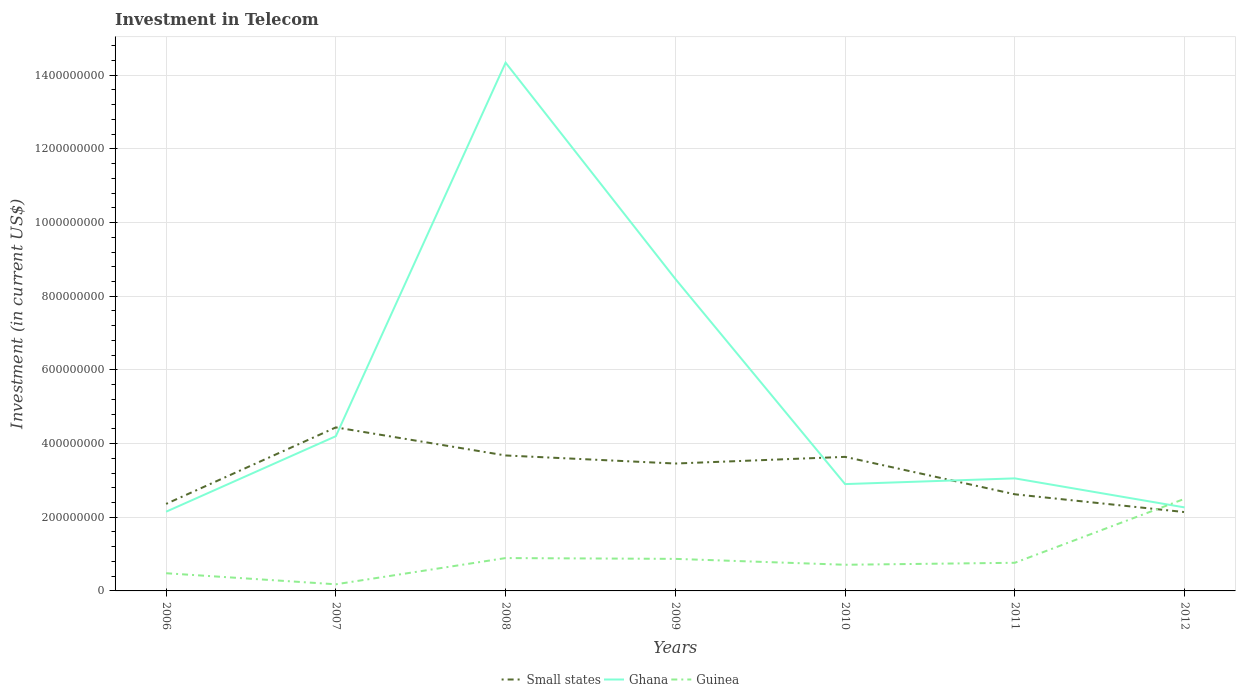Does the line corresponding to Ghana intersect with the line corresponding to Guinea?
Provide a short and direct response. Yes. Across all years, what is the maximum amount invested in telecom in Ghana?
Make the answer very short. 2.15e+08. In which year was the amount invested in telecom in Ghana maximum?
Provide a succinct answer. 2006. What is the total amount invested in telecom in Guinea in the graph?
Your answer should be very brief. -1.63e+08. What is the difference between the highest and the second highest amount invested in telecom in Ghana?
Provide a short and direct response. 1.22e+09. What is the difference between the highest and the lowest amount invested in telecom in Small states?
Make the answer very short. 4. Is the amount invested in telecom in Small states strictly greater than the amount invested in telecom in Guinea over the years?
Your answer should be very brief. No. Are the values on the major ticks of Y-axis written in scientific E-notation?
Ensure brevity in your answer.  No. Does the graph contain any zero values?
Give a very brief answer. No. Where does the legend appear in the graph?
Your answer should be compact. Bottom center. What is the title of the graph?
Give a very brief answer. Investment in Telecom. Does "Malta" appear as one of the legend labels in the graph?
Your response must be concise. No. What is the label or title of the X-axis?
Offer a terse response. Years. What is the label or title of the Y-axis?
Ensure brevity in your answer.  Investment (in current US$). What is the Investment (in current US$) in Small states in 2006?
Ensure brevity in your answer.  2.36e+08. What is the Investment (in current US$) in Ghana in 2006?
Offer a terse response. 2.15e+08. What is the Investment (in current US$) of Guinea in 2006?
Your response must be concise. 4.80e+07. What is the Investment (in current US$) of Small states in 2007?
Provide a short and direct response. 4.44e+08. What is the Investment (in current US$) of Ghana in 2007?
Keep it short and to the point. 4.20e+08. What is the Investment (in current US$) of Guinea in 2007?
Keep it short and to the point. 1.80e+07. What is the Investment (in current US$) of Small states in 2008?
Offer a very short reply. 3.68e+08. What is the Investment (in current US$) in Ghana in 2008?
Give a very brief answer. 1.43e+09. What is the Investment (in current US$) of Guinea in 2008?
Offer a terse response. 8.92e+07. What is the Investment (in current US$) in Small states in 2009?
Give a very brief answer. 3.46e+08. What is the Investment (in current US$) in Ghana in 2009?
Your answer should be compact. 8.47e+08. What is the Investment (in current US$) in Guinea in 2009?
Make the answer very short. 8.70e+07. What is the Investment (in current US$) of Small states in 2010?
Your answer should be compact. 3.64e+08. What is the Investment (in current US$) in Ghana in 2010?
Your response must be concise. 2.90e+08. What is the Investment (in current US$) in Guinea in 2010?
Offer a terse response. 7.10e+07. What is the Investment (in current US$) of Small states in 2011?
Your response must be concise. 2.62e+08. What is the Investment (in current US$) in Ghana in 2011?
Ensure brevity in your answer.  3.06e+08. What is the Investment (in current US$) in Guinea in 2011?
Provide a succinct answer. 7.64e+07. What is the Investment (in current US$) in Small states in 2012?
Make the answer very short. 2.14e+08. What is the Investment (in current US$) in Ghana in 2012?
Give a very brief answer. 2.27e+08. What is the Investment (in current US$) of Guinea in 2012?
Offer a terse response. 2.50e+08. Across all years, what is the maximum Investment (in current US$) in Small states?
Ensure brevity in your answer.  4.44e+08. Across all years, what is the maximum Investment (in current US$) in Ghana?
Ensure brevity in your answer.  1.43e+09. Across all years, what is the maximum Investment (in current US$) of Guinea?
Offer a very short reply. 2.50e+08. Across all years, what is the minimum Investment (in current US$) of Small states?
Offer a terse response. 2.14e+08. Across all years, what is the minimum Investment (in current US$) in Ghana?
Offer a terse response. 2.15e+08. Across all years, what is the minimum Investment (in current US$) in Guinea?
Give a very brief answer. 1.80e+07. What is the total Investment (in current US$) of Small states in the graph?
Offer a very short reply. 2.23e+09. What is the total Investment (in current US$) of Ghana in the graph?
Offer a very short reply. 3.74e+09. What is the total Investment (in current US$) of Guinea in the graph?
Your answer should be compact. 6.40e+08. What is the difference between the Investment (in current US$) in Small states in 2006 and that in 2007?
Offer a very short reply. -2.08e+08. What is the difference between the Investment (in current US$) in Ghana in 2006 and that in 2007?
Provide a short and direct response. -2.05e+08. What is the difference between the Investment (in current US$) in Guinea in 2006 and that in 2007?
Give a very brief answer. 3.00e+07. What is the difference between the Investment (in current US$) of Small states in 2006 and that in 2008?
Give a very brief answer. -1.31e+08. What is the difference between the Investment (in current US$) in Ghana in 2006 and that in 2008?
Keep it short and to the point. -1.22e+09. What is the difference between the Investment (in current US$) of Guinea in 2006 and that in 2008?
Provide a short and direct response. -4.12e+07. What is the difference between the Investment (in current US$) of Small states in 2006 and that in 2009?
Provide a succinct answer. -1.10e+08. What is the difference between the Investment (in current US$) in Ghana in 2006 and that in 2009?
Offer a terse response. -6.32e+08. What is the difference between the Investment (in current US$) of Guinea in 2006 and that in 2009?
Your answer should be compact. -3.90e+07. What is the difference between the Investment (in current US$) in Small states in 2006 and that in 2010?
Keep it short and to the point. -1.28e+08. What is the difference between the Investment (in current US$) of Ghana in 2006 and that in 2010?
Your response must be concise. -7.50e+07. What is the difference between the Investment (in current US$) of Guinea in 2006 and that in 2010?
Your answer should be compact. -2.30e+07. What is the difference between the Investment (in current US$) in Small states in 2006 and that in 2011?
Give a very brief answer. -2.61e+07. What is the difference between the Investment (in current US$) of Ghana in 2006 and that in 2011?
Offer a very short reply. -9.05e+07. What is the difference between the Investment (in current US$) of Guinea in 2006 and that in 2011?
Keep it short and to the point. -2.84e+07. What is the difference between the Investment (in current US$) in Small states in 2006 and that in 2012?
Provide a short and direct response. 2.22e+07. What is the difference between the Investment (in current US$) of Ghana in 2006 and that in 2012?
Ensure brevity in your answer.  -1.17e+07. What is the difference between the Investment (in current US$) of Guinea in 2006 and that in 2012?
Ensure brevity in your answer.  -2.02e+08. What is the difference between the Investment (in current US$) in Small states in 2007 and that in 2008?
Offer a terse response. 7.62e+07. What is the difference between the Investment (in current US$) in Ghana in 2007 and that in 2008?
Offer a very short reply. -1.01e+09. What is the difference between the Investment (in current US$) of Guinea in 2007 and that in 2008?
Offer a very short reply. -7.12e+07. What is the difference between the Investment (in current US$) of Small states in 2007 and that in 2009?
Ensure brevity in your answer.  9.81e+07. What is the difference between the Investment (in current US$) of Ghana in 2007 and that in 2009?
Your answer should be very brief. -4.27e+08. What is the difference between the Investment (in current US$) of Guinea in 2007 and that in 2009?
Provide a short and direct response. -6.90e+07. What is the difference between the Investment (in current US$) of Small states in 2007 and that in 2010?
Your answer should be very brief. 8.00e+07. What is the difference between the Investment (in current US$) of Ghana in 2007 and that in 2010?
Offer a very short reply. 1.30e+08. What is the difference between the Investment (in current US$) in Guinea in 2007 and that in 2010?
Make the answer very short. -5.30e+07. What is the difference between the Investment (in current US$) in Small states in 2007 and that in 2011?
Offer a terse response. 1.82e+08. What is the difference between the Investment (in current US$) of Ghana in 2007 and that in 2011?
Offer a terse response. 1.14e+08. What is the difference between the Investment (in current US$) of Guinea in 2007 and that in 2011?
Keep it short and to the point. -5.84e+07. What is the difference between the Investment (in current US$) in Small states in 2007 and that in 2012?
Your answer should be compact. 2.30e+08. What is the difference between the Investment (in current US$) of Ghana in 2007 and that in 2012?
Provide a succinct answer. 1.93e+08. What is the difference between the Investment (in current US$) in Guinea in 2007 and that in 2012?
Your answer should be compact. -2.32e+08. What is the difference between the Investment (in current US$) of Small states in 2008 and that in 2009?
Keep it short and to the point. 2.19e+07. What is the difference between the Investment (in current US$) in Ghana in 2008 and that in 2009?
Keep it short and to the point. 5.87e+08. What is the difference between the Investment (in current US$) in Guinea in 2008 and that in 2009?
Offer a very short reply. 2.20e+06. What is the difference between the Investment (in current US$) of Small states in 2008 and that in 2010?
Offer a terse response. 3.81e+06. What is the difference between the Investment (in current US$) of Ghana in 2008 and that in 2010?
Make the answer very short. 1.14e+09. What is the difference between the Investment (in current US$) in Guinea in 2008 and that in 2010?
Give a very brief answer. 1.82e+07. What is the difference between the Investment (in current US$) in Small states in 2008 and that in 2011?
Provide a succinct answer. 1.05e+08. What is the difference between the Investment (in current US$) in Ghana in 2008 and that in 2011?
Offer a very short reply. 1.13e+09. What is the difference between the Investment (in current US$) of Guinea in 2008 and that in 2011?
Provide a succinct answer. 1.28e+07. What is the difference between the Investment (in current US$) of Small states in 2008 and that in 2012?
Provide a succinct answer. 1.54e+08. What is the difference between the Investment (in current US$) of Ghana in 2008 and that in 2012?
Your answer should be very brief. 1.21e+09. What is the difference between the Investment (in current US$) in Guinea in 2008 and that in 2012?
Your answer should be very brief. -1.61e+08. What is the difference between the Investment (in current US$) of Small states in 2009 and that in 2010?
Offer a terse response. -1.81e+07. What is the difference between the Investment (in current US$) of Ghana in 2009 and that in 2010?
Your answer should be very brief. 5.57e+08. What is the difference between the Investment (in current US$) in Guinea in 2009 and that in 2010?
Ensure brevity in your answer.  1.60e+07. What is the difference between the Investment (in current US$) in Small states in 2009 and that in 2011?
Your response must be concise. 8.35e+07. What is the difference between the Investment (in current US$) in Ghana in 2009 and that in 2011?
Your answer should be very brief. 5.42e+08. What is the difference between the Investment (in current US$) of Guinea in 2009 and that in 2011?
Make the answer very short. 1.06e+07. What is the difference between the Investment (in current US$) of Small states in 2009 and that in 2012?
Keep it short and to the point. 1.32e+08. What is the difference between the Investment (in current US$) of Ghana in 2009 and that in 2012?
Offer a terse response. 6.20e+08. What is the difference between the Investment (in current US$) in Guinea in 2009 and that in 2012?
Ensure brevity in your answer.  -1.63e+08. What is the difference between the Investment (in current US$) in Small states in 2010 and that in 2011?
Your answer should be compact. 1.02e+08. What is the difference between the Investment (in current US$) of Ghana in 2010 and that in 2011?
Your response must be concise. -1.55e+07. What is the difference between the Investment (in current US$) in Guinea in 2010 and that in 2011?
Your answer should be very brief. -5.40e+06. What is the difference between the Investment (in current US$) in Small states in 2010 and that in 2012?
Provide a short and direct response. 1.50e+08. What is the difference between the Investment (in current US$) of Ghana in 2010 and that in 2012?
Make the answer very short. 6.33e+07. What is the difference between the Investment (in current US$) in Guinea in 2010 and that in 2012?
Provide a succinct answer. -1.79e+08. What is the difference between the Investment (in current US$) in Small states in 2011 and that in 2012?
Offer a very short reply. 4.83e+07. What is the difference between the Investment (in current US$) in Ghana in 2011 and that in 2012?
Ensure brevity in your answer.  7.88e+07. What is the difference between the Investment (in current US$) in Guinea in 2011 and that in 2012?
Give a very brief answer. -1.74e+08. What is the difference between the Investment (in current US$) of Small states in 2006 and the Investment (in current US$) of Ghana in 2007?
Ensure brevity in your answer.  -1.84e+08. What is the difference between the Investment (in current US$) of Small states in 2006 and the Investment (in current US$) of Guinea in 2007?
Offer a very short reply. 2.18e+08. What is the difference between the Investment (in current US$) in Ghana in 2006 and the Investment (in current US$) in Guinea in 2007?
Your answer should be very brief. 1.97e+08. What is the difference between the Investment (in current US$) in Small states in 2006 and the Investment (in current US$) in Ghana in 2008?
Your response must be concise. -1.20e+09. What is the difference between the Investment (in current US$) in Small states in 2006 and the Investment (in current US$) in Guinea in 2008?
Your answer should be compact. 1.47e+08. What is the difference between the Investment (in current US$) of Ghana in 2006 and the Investment (in current US$) of Guinea in 2008?
Provide a short and direct response. 1.26e+08. What is the difference between the Investment (in current US$) of Small states in 2006 and the Investment (in current US$) of Ghana in 2009?
Offer a very short reply. -6.11e+08. What is the difference between the Investment (in current US$) of Small states in 2006 and the Investment (in current US$) of Guinea in 2009?
Your answer should be very brief. 1.49e+08. What is the difference between the Investment (in current US$) in Ghana in 2006 and the Investment (in current US$) in Guinea in 2009?
Your answer should be very brief. 1.28e+08. What is the difference between the Investment (in current US$) of Small states in 2006 and the Investment (in current US$) of Ghana in 2010?
Offer a very short reply. -5.38e+07. What is the difference between the Investment (in current US$) of Small states in 2006 and the Investment (in current US$) of Guinea in 2010?
Offer a very short reply. 1.65e+08. What is the difference between the Investment (in current US$) of Ghana in 2006 and the Investment (in current US$) of Guinea in 2010?
Your answer should be very brief. 1.44e+08. What is the difference between the Investment (in current US$) in Small states in 2006 and the Investment (in current US$) in Ghana in 2011?
Offer a terse response. -6.93e+07. What is the difference between the Investment (in current US$) in Small states in 2006 and the Investment (in current US$) in Guinea in 2011?
Provide a succinct answer. 1.60e+08. What is the difference between the Investment (in current US$) of Ghana in 2006 and the Investment (in current US$) of Guinea in 2011?
Keep it short and to the point. 1.39e+08. What is the difference between the Investment (in current US$) in Small states in 2006 and the Investment (in current US$) in Ghana in 2012?
Make the answer very short. 9.53e+06. What is the difference between the Investment (in current US$) of Small states in 2006 and the Investment (in current US$) of Guinea in 2012?
Offer a terse response. -1.38e+07. What is the difference between the Investment (in current US$) in Ghana in 2006 and the Investment (in current US$) in Guinea in 2012?
Offer a terse response. -3.50e+07. What is the difference between the Investment (in current US$) in Small states in 2007 and the Investment (in current US$) in Ghana in 2008?
Your answer should be very brief. -9.90e+08. What is the difference between the Investment (in current US$) of Small states in 2007 and the Investment (in current US$) of Guinea in 2008?
Your response must be concise. 3.55e+08. What is the difference between the Investment (in current US$) of Ghana in 2007 and the Investment (in current US$) of Guinea in 2008?
Your answer should be very brief. 3.31e+08. What is the difference between the Investment (in current US$) in Small states in 2007 and the Investment (in current US$) in Ghana in 2009?
Your answer should be compact. -4.03e+08. What is the difference between the Investment (in current US$) in Small states in 2007 and the Investment (in current US$) in Guinea in 2009?
Keep it short and to the point. 3.57e+08. What is the difference between the Investment (in current US$) in Ghana in 2007 and the Investment (in current US$) in Guinea in 2009?
Offer a very short reply. 3.33e+08. What is the difference between the Investment (in current US$) in Small states in 2007 and the Investment (in current US$) in Ghana in 2010?
Provide a short and direct response. 1.54e+08. What is the difference between the Investment (in current US$) of Small states in 2007 and the Investment (in current US$) of Guinea in 2010?
Offer a very short reply. 3.73e+08. What is the difference between the Investment (in current US$) of Ghana in 2007 and the Investment (in current US$) of Guinea in 2010?
Make the answer very short. 3.49e+08. What is the difference between the Investment (in current US$) of Small states in 2007 and the Investment (in current US$) of Ghana in 2011?
Keep it short and to the point. 1.38e+08. What is the difference between the Investment (in current US$) of Small states in 2007 and the Investment (in current US$) of Guinea in 2011?
Provide a short and direct response. 3.68e+08. What is the difference between the Investment (in current US$) in Ghana in 2007 and the Investment (in current US$) in Guinea in 2011?
Give a very brief answer. 3.44e+08. What is the difference between the Investment (in current US$) in Small states in 2007 and the Investment (in current US$) in Ghana in 2012?
Offer a terse response. 2.17e+08. What is the difference between the Investment (in current US$) in Small states in 2007 and the Investment (in current US$) in Guinea in 2012?
Offer a terse response. 1.94e+08. What is the difference between the Investment (in current US$) of Ghana in 2007 and the Investment (in current US$) of Guinea in 2012?
Offer a terse response. 1.70e+08. What is the difference between the Investment (in current US$) in Small states in 2008 and the Investment (in current US$) in Ghana in 2009?
Provide a short and direct response. -4.79e+08. What is the difference between the Investment (in current US$) in Small states in 2008 and the Investment (in current US$) in Guinea in 2009?
Give a very brief answer. 2.81e+08. What is the difference between the Investment (in current US$) of Ghana in 2008 and the Investment (in current US$) of Guinea in 2009?
Give a very brief answer. 1.35e+09. What is the difference between the Investment (in current US$) of Small states in 2008 and the Investment (in current US$) of Ghana in 2010?
Your answer should be compact. 7.77e+07. What is the difference between the Investment (in current US$) of Small states in 2008 and the Investment (in current US$) of Guinea in 2010?
Ensure brevity in your answer.  2.97e+08. What is the difference between the Investment (in current US$) of Ghana in 2008 and the Investment (in current US$) of Guinea in 2010?
Offer a very short reply. 1.36e+09. What is the difference between the Investment (in current US$) in Small states in 2008 and the Investment (in current US$) in Ghana in 2011?
Your answer should be compact. 6.22e+07. What is the difference between the Investment (in current US$) of Small states in 2008 and the Investment (in current US$) of Guinea in 2011?
Provide a short and direct response. 2.91e+08. What is the difference between the Investment (in current US$) in Ghana in 2008 and the Investment (in current US$) in Guinea in 2011?
Make the answer very short. 1.36e+09. What is the difference between the Investment (in current US$) of Small states in 2008 and the Investment (in current US$) of Ghana in 2012?
Your response must be concise. 1.41e+08. What is the difference between the Investment (in current US$) of Small states in 2008 and the Investment (in current US$) of Guinea in 2012?
Your answer should be compact. 1.18e+08. What is the difference between the Investment (in current US$) in Ghana in 2008 and the Investment (in current US$) in Guinea in 2012?
Your answer should be very brief. 1.18e+09. What is the difference between the Investment (in current US$) of Small states in 2009 and the Investment (in current US$) of Ghana in 2010?
Offer a very short reply. 5.58e+07. What is the difference between the Investment (in current US$) in Small states in 2009 and the Investment (in current US$) in Guinea in 2010?
Ensure brevity in your answer.  2.75e+08. What is the difference between the Investment (in current US$) of Ghana in 2009 and the Investment (in current US$) of Guinea in 2010?
Offer a very short reply. 7.76e+08. What is the difference between the Investment (in current US$) of Small states in 2009 and the Investment (in current US$) of Ghana in 2011?
Provide a succinct answer. 4.03e+07. What is the difference between the Investment (in current US$) in Small states in 2009 and the Investment (in current US$) in Guinea in 2011?
Your answer should be very brief. 2.69e+08. What is the difference between the Investment (in current US$) of Ghana in 2009 and the Investment (in current US$) of Guinea in 2011?
Your response must be concise. 7.71e+08. What is the difference between the Investment (in current US$) of Small states in 2009 and the Investment (in current US$) of Ghana in 2012?
Make the answer very short. 1.19e+08. What is the difference between the Investment (in current US$) of Small states in 2009 and the Investment (in current US$) of Guinea in 2012?
Offer a very short reply. 9.58e+07. What is the difference between the Investment (in current US$) of Ghana in 2009 and the Investment (in current US$) of Guinea in 2012?
Provide a succinct answer. 5.97e+08. What is the difference between the Investment (in current US$) of Small states in 2010 and the Investment (in current US$) of Ghana in 2011?
Keep it short and to the point. 5.84e+07. What is the difference between the Investment (in current US$) of Small states in 2010 and the Investment (in current US$) of Guinea in 2011?
Offer a terse response. 2.88e+08. What is the difference between the Investment (in current US$) in Ghana in 2010 and the Investment (in current US$) in Guinea in 2011?
Offer a terse response. 2.14e+08. What is the difference between the Investment (in current US$) of Small states in 2010 and the Investment (in current US$) of Ghana in 2012?
Give a very brief answer. 1.37e+08. What is the difference between the Investment (in current US$) in Small states in 2010 and the Investment (in current US$) in Guinea in 2012?
Your answer should be very brief. 1.14e+08. What is the difference between the Investment (in current US$) of Ghana in 2010 and the Investment (in current US$) of Guinea in 2012?
Give a very brief answer. 4.00e+07. What is the difference between the Investment (in current US$) in Small states in 2011 and the Investment (in current US$) in Ghana in 2012?
Your answer should be compact. 3.56e+07. What is the difference between the Investment (in current US$) in Small states in 2011 and the Investment (in current US$) in Guinea in 2012?
Your answer should be very brief. 1.23e+07. What is the difference between the Investment (in current US$) in Ghana in 2011 and the Investment (in current US$) in Guinea in 2012?
Give a very brief answer. 5.55e+07. What is the average Investment (in current US$) in Small states per year?
Your response must be concise. 3.19e+08. What is the average Investment (in current US$) of Ghana per year?
Keep it short and to the point. 5.34e+08. What is the average Investment (in current US$) of Guinea per year?
Offer a terse response. 9.14e+07. In the year 2006, what is the difference between the Investment (in current US$) in Small states and Investment (in current US$) in Ghana?
Offer a terse response. 2.12e+07. In the year 2006, what is the difference between the Investment (in current US$) of Small states and Investment (in current US$) of Guinea?
Keep it short and to the point. 1.88e+08. In the year 2006, what is the difference between the Investment (in current US$) of Ghana and Investment (in current US$) of Guinea?
Offer a very short reply. 1.67e+08. In the year 2007, what is the difference between the Investment (in current US$) of Small states and Investment (in current US$) of Ghana?
Offer a terse response. 2.39e+07. In the year 2007, what is the difference between the Investment (in current US$) in Small states and Investment (in current US$) in Guinea?
Your answer should be very brief. 4.26e+08. In the year 2007, what is the difference between the Investment (in current US$) of Ghana and Investment (in current US$) of Guinea?
Make the answer very short. 4.02e+08. In the year 2008, what is the difference between the Investment (in current US$) in Small states and Investment (in current US$) in Ghana?
Your answer should be compact. -1.07e+09. In the year 2008, what is the difference between the Investment (in current US$) of Small states and Investment (in current US$) of Guinea?
Offer a terse response. 2.79e+08. In the year 2008, what is the difference between the Investment (in current US$) in Ghana and Investment (in current US$) in Guinea?
Keep it short and to the point. 1.34e+09. In the year 2009, what is the difference between the Investment (in current US$) of Small states and Investment (in current US$) of Ghana?
Your answer should be compact. -5.01e+08. In the year 2009, what is the difference between the Investment (in current US$) in Small states and Investment (in current US$) in Guinea?
Your response must be concise. 2.59e+08. In the year 2009, what is the difference between the Investment (in current US$) in Ghana and Investment (in current US$) in Guinea?
Make the answer very short. 7.60e+08. In the year 2010, what is the difference between the Investment (in current US$) of Small states and Investment (in current US$) of Ghana?
Keep it short and to the point. 7.39e+07. In the year 2010, what is the difference between the Investment (in current US$) of Small states and Investment (in current US$) of Guinea?
Your response must be concise. 2.93e+08. In the year 2010, what is the difference between the Investment (in current US$) of Ghana and Investment (in current US$) of Guinea?
Provide a short and direct response. 2.19e+08. In the year 2011, what is the difference between the Investment (in current US$) of Small states and Investment (in current US$) of Ghana?
Offer a very short reply. -4.32e+07. In the year 2011, what is the difference between the Investment (in current US$) of Small states and Investment (in current US$) of Guinea?
Offer a very short reply. 1.86e+08. In the year 2011, what is the difference between the Investment (in current US$) in Ghana and Investment (in current US$) in Guinea?
Ensure brevity in your answer.  2.29e+08. In the year 2012, what is the difference between the Investment (in current US$) in Small states and Investment (in current US$) in Ghana?
Your answer should be compact. -1.27e+07. In the year 2012, what is the difference between the Investment (in current US$) in Small states and Investment (in current US$) in Guinea?
Your answer should be very brief. -3.60e+07. In the year 2012, what is the difference between the Investment (in current US$) of Ghana and Investment (in current US$) of Guinea?
Offer a terse response. -2.33e+07. What is the ratio of the Investment (in current US$) of Small states in 2006 to that in 2007?
Your answer should be very brief. 0.53. What is the ratio of the Investment (in current US$) in Ghana in 2006 to that in 2007?
Provide a short and direct response. 0.51. What is the ratio of the Investment (in current US$) of Guinea in 2006 to that in 2007?
Provide a succinct answer. 2.67. What is the ratio of the Investment (in current US$) of Small states in 2006 to that in 2008?
Your answer should be compact. 0.64. What is the ratio of the Investment (in current US$) of Ghana in 2006 to that in 2008?
Your response must be concise. 0.15. What is the ratio of the Investment (in current US$) of Guinea in 2006 to that in 2008?
Keep it short and to the point. 0.54. What is the ratio of the Investment (in current US$) in Small states in 2006 to that in 2009?
Your answer should be compact. 0.68. What is the ratio of the Investment (in current US$) in Ghana in 2006 to that in 2009?
Your answer should be very brief. 0.25. What is the ratio of the Investment (in current US$) in Guinea in 2006 to that in 2009?
Your response must be concise. 0.55. What is the ratio of the Investment (in current US$) in Small states in 2006 to that in 2010?
Provide a succinct answer. 0.65. What is the ratio of the Investment (in current US$) of Ghana in 2006 to that in 2010?
Make the answer very short. 0.74. What is the ratio of the Investment (in current US$) in Guinea in 2006 to that in 2010?
Your response must be concise. 0.68. What is the ratio of the Investment (in current US$) in Small states in 2006 to that in 2011?
Provide a short and direct response. 0.9. What is the ratio of the Investment (in current US$) of Ghana in 2006 to that in 2011?
Keep it short and to the point. 0.7. What is the ratio of the Investment (in current US$) in Guinea in 2006 to that in 2011?
Your answer should be compact. 0.63. What is the ratio of the Investment (in current US$) in Small states in 2006 to that in 2012?
Give a very brief answer. 1.1. What is the ratio of the Investment (in current US$) of Ghana in 2006 to that in 2012?
Offer a terse response. 0.95. What is the ratio of the Investment (in current US$) in Guinea in 2006 to that in 2012?
Your response must be concise. 0.19. What is the ratio of the Investment (in current US$) in Small states in 2007 to that in 2008?
Make the answer very short. 1.21. What is the ratio of the Investment (in current US$) in Ghana in 2007 to that in 2008?
Make the answer very short. 0.29. What is the ratio of the Investment (in current US$) in Guinea in 2007 to that in 2008?
Your answer should be compact. 0.2. What is the ratio of the Investment (in current US$) of Small states in 2007 to that in 2009?
Give a very brief answer. 1.28. What is the ratio of the Investment (in current US$) of Ghana in 2007 to that in 2009?
Provide a short and direct response. 0.5. What is the ratio of the Investment (in current US$) in Guinea in 2007 to that in 2009?
Provide a succinct answer. 0.21. What is the ratio of the Investment (in current US$) of Small states in 2007 to that in 2010?
Provide a short and direct response. 1.22. What is the ratio of the Investment (in current US$) in Ghana in 2007 to that in 2010?
Your answer should be compact. 1.45. What is the ratio of the Investment (in current US$) in Guinea in 2007 to that in 2010?
Your response must be concise. 0.25. What is the ratio of the Investment (in current US$) of Small states in 2007 to that in 2011?
Give a very brief answer. 1.69. What is the ratio of the Investment (in current US$) in Ghana in 2007 to that in 2011?
Provide a short and direct response. 1.37. What is the ratio of the Investment (in current US$) in Guinea in 2007 to that in 2011?
Give a very brief answer. 0.24. What is the ratio of the Investment (in current US$) in Small states in 2007 to that in 2012?
Provide a short and direct response. 2.07. What is the ratio of the Investment (in current US$) in Ghana in 2007 to that in 2012?
Offer a terse response. 1.85. What is the ratio of the Investment (in current US$) in Guinea in 2007 to that in 2012?
Ensure brevity in your answer.  0.07. What is the ratio of the Investment (in current US$) of Small states in 2008 to that in 2009?
Your answer should be compact. 1.06. What is the ratio of the Investment (in current US$) of Ghana in 2008 to that in 2009?
Offer a terse response. 1.69. What is the ratio of the Investment (in current US$) of Guinea in 2008 to that in 2009?
Keep it short and to the point. 1.03. What is the ratio of the Investment (in current US$) in Small states in 2008 to that in 2010?
Your answer should be compact. 1.01. What is the ratio of the Investment (in current US$) of Ghana in 2008 to that in 2010?
Keep it short and to the point. 4.94. What is the ratio of the Investment (in current US$) in Guinea in 2008 to that in 2010?
Your answer should be very brief. 1.26. What is the ratio of the Investment (in current US$) in Small states in 2008 to that in 2011?
Keep it short and to the point. 1.4. What is the ratio of the Investment (in current US$) of Ghana in 2008 to that in 2011?
Provide a succinct answer. 4.69. What is the ratio of the Investment (in current US$) in Guinea in 2008 to that in 2011?
Your answer should be compact. 1.17. What is the ratio of the Investment (in current US$) of Small states in 2008 to that in 2012?
Offer a very short reply. 1.72. What is the ratio of the Investment (in current US$) in Ghana in 2008 to that in 2012?
Offer a terse response. 6.33. What is the ratio of the Investment (in current US$) of Guinea in 2008 to that in 2012?
Give a very brief answer. 0.36. What is the ratio of the Investment (in current US$) of Small states in 2009 to that in 2010?
Provide a short and direct response. 0.95. What is the ratio of the Investment (in current US$) in Ghana in 2009 to that in 2010?
Your response must be concise. 2.92. What is the ratio of the Investment (in current US$) in Guinea in 2009 to that in 2010?
Your answer should be very brief. 1.23. What is the ratio of the Investment (in current US$) in Small states in 2009 to that in 2011?
Give a very brief answer. 1.32. What is the ratio of the Investment (in current US$) of Ghana in 2009 to that in 2011?
Provide a succinct answer. 2.77. What is the ratio of the Investment (in current US$) in Guinea in 2009 to that in 2011?
Offer a terse response. 1.14. What is the ratio of the Investment (in current US$) of Small states in 2009 to that in 2012?
Give a very brief answer. 1.62. What is the ratio of the Investment (in current US$) in Ghana in 2009 to that in 2012?
Your answer should be very brief. 3.74. What is the ratio of the Investment (in current US$) of Guinea in 2009 to that in 2012?
Give a very brief answer. 0.35. What is the ratio of the Investment (in current US$) of Small states in 2010 to that in 2011?
Ensure brevity in your answer.  1.39. What is the ratio of the Investment (in current US$) in Ghana in 2010 to that in 2011?
Give a very brief answer. 0.95. What is the ratio of the Investment (in current US$) in Guinea in 2010 to that in 2011?
Your answer should be very brief. 0.93. What is the ratio of the Investment (in current US$) of Small states in 2010 to that in 2012?
Provide a short and direct response. 1.7. What is the ratio of the Investment (in current US$) of Ghana in 2010 to that in 2012?
Keep it short and to the point. 1.28. What is the ratio of the Investment (in current US$) of Guinea in 2010 to that in 2012?
Ensure brevity in your answer.  0.28. What is the ratio of the Investment (in current US$) of Small states in 2011 to that in 2012?
Offer a very short reply. 1.23. What is the ratio of the Investment (in current US$) in Ghana in 2011 to that in 2012?
Offer a very short reply. 1.35. What is the ratio of the Investment (in current US$) of Guinea in 2011 to that in 2012?
Provide a short and direct response. 0.31. What is the difference between the highest and the second highest Investment (in current US$) in Small states?
Offer a very short reply. 7.62e+07. What is the difference between the highest and the second highest Investment (in current US$) of Ghana?
Your answer should be very brief. 5.87e+08. What is the difference between the highest and the second highest Investment (in current US$) of Guinea?
Provide a succinct answer. 1.61e+08. What is the difference between the highest and the lowest Investment (in current US$) of Small states?
Provide a succinct answer. 2.30e+08. What is the difference between the highest and the lowest Investment (in current US$) in Ghana?
Give a very brief answer. 1.22e+09. What is the difference between the highest and the lowest Investment (in current US$) in Guinea?
Give a very brief answer. 2.32e+08. 